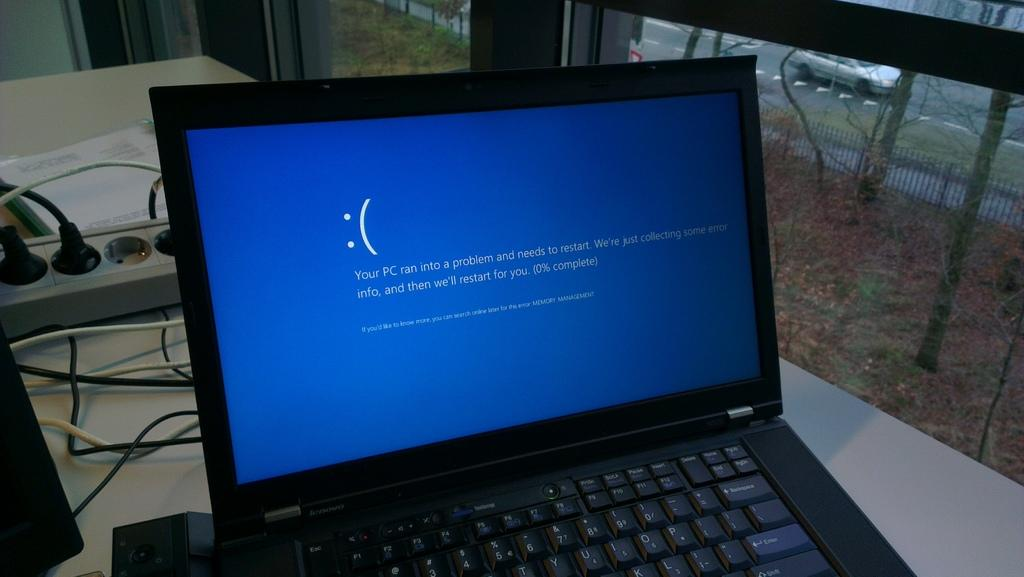<image>
Offer a succinct explanation of the picture presented. A black Lenovo laptop displays a blue screen and an error message. 